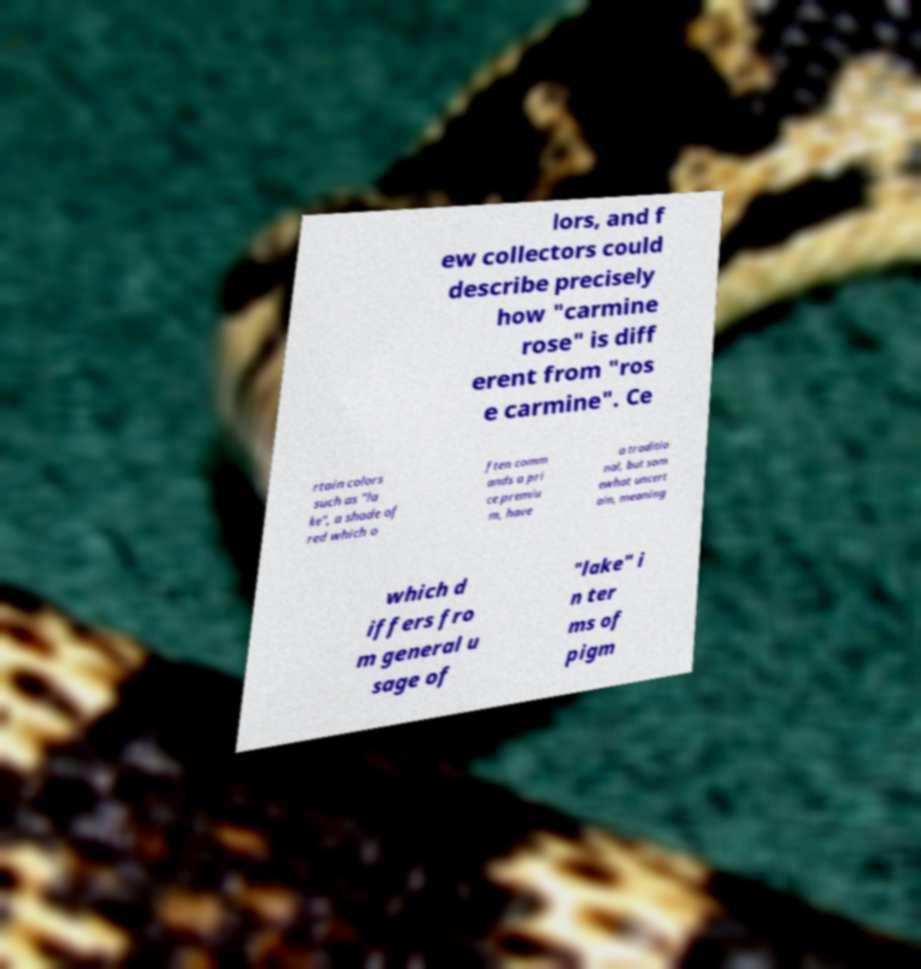Can you accurately transcribe the text from the provided image for me? lors, and f ew collectors could describe precisely how "carmine rose" is diff erent from "ros e carmine". Ce rtain colors such as "la ke", a shade of red which o ften comm ands a pri ce premiu m, have a traditio nal, but som ewhat uncert ain, meaning which d iffers fro m general u sage of "lake" i n ter ms of pigm 